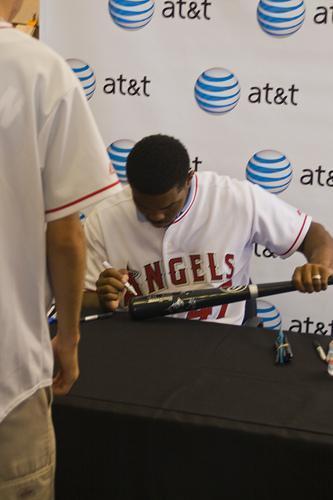How many men are signing the bat?
Give a very brief answer. 1. How many people are there?
Give a very brief answer. 2. 